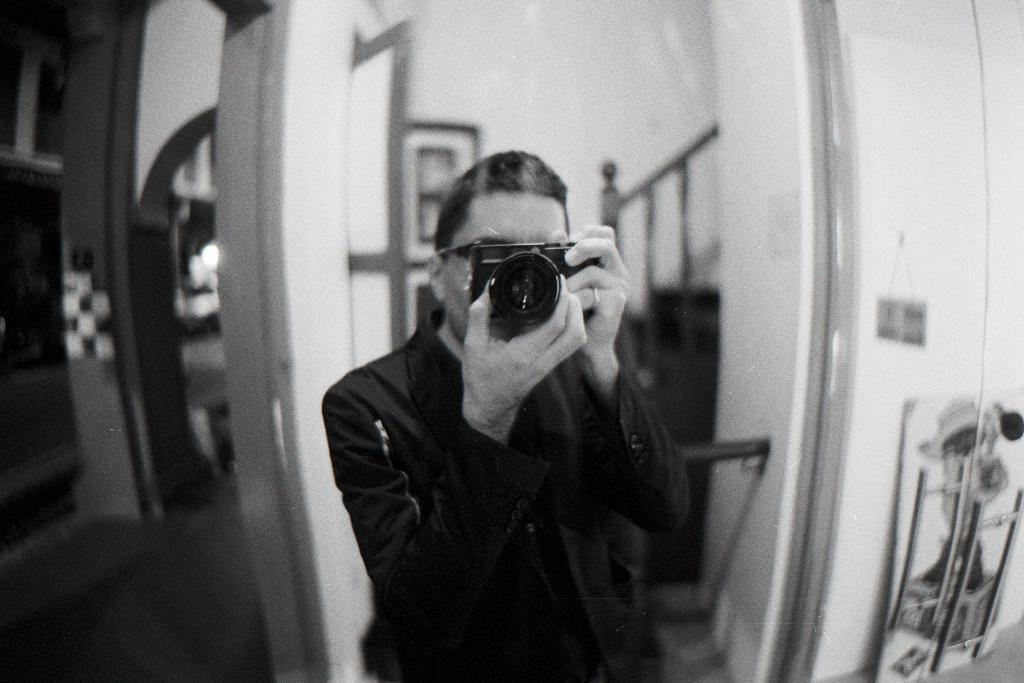What is the person in the image doing? The person is standing and holding a camera in the image. What object is the person holding? The person is holding a camera. What can be seen on the right side of the image? There is a stand on the right side of the image. What elements are visible in the background of the image? There is a wall, a pillar, a window, a photo frame, and staircases in the background of the image. What type of joke is being told by the person holding the spade in the image? There is no person holding a spade or telling a joke in the image. 